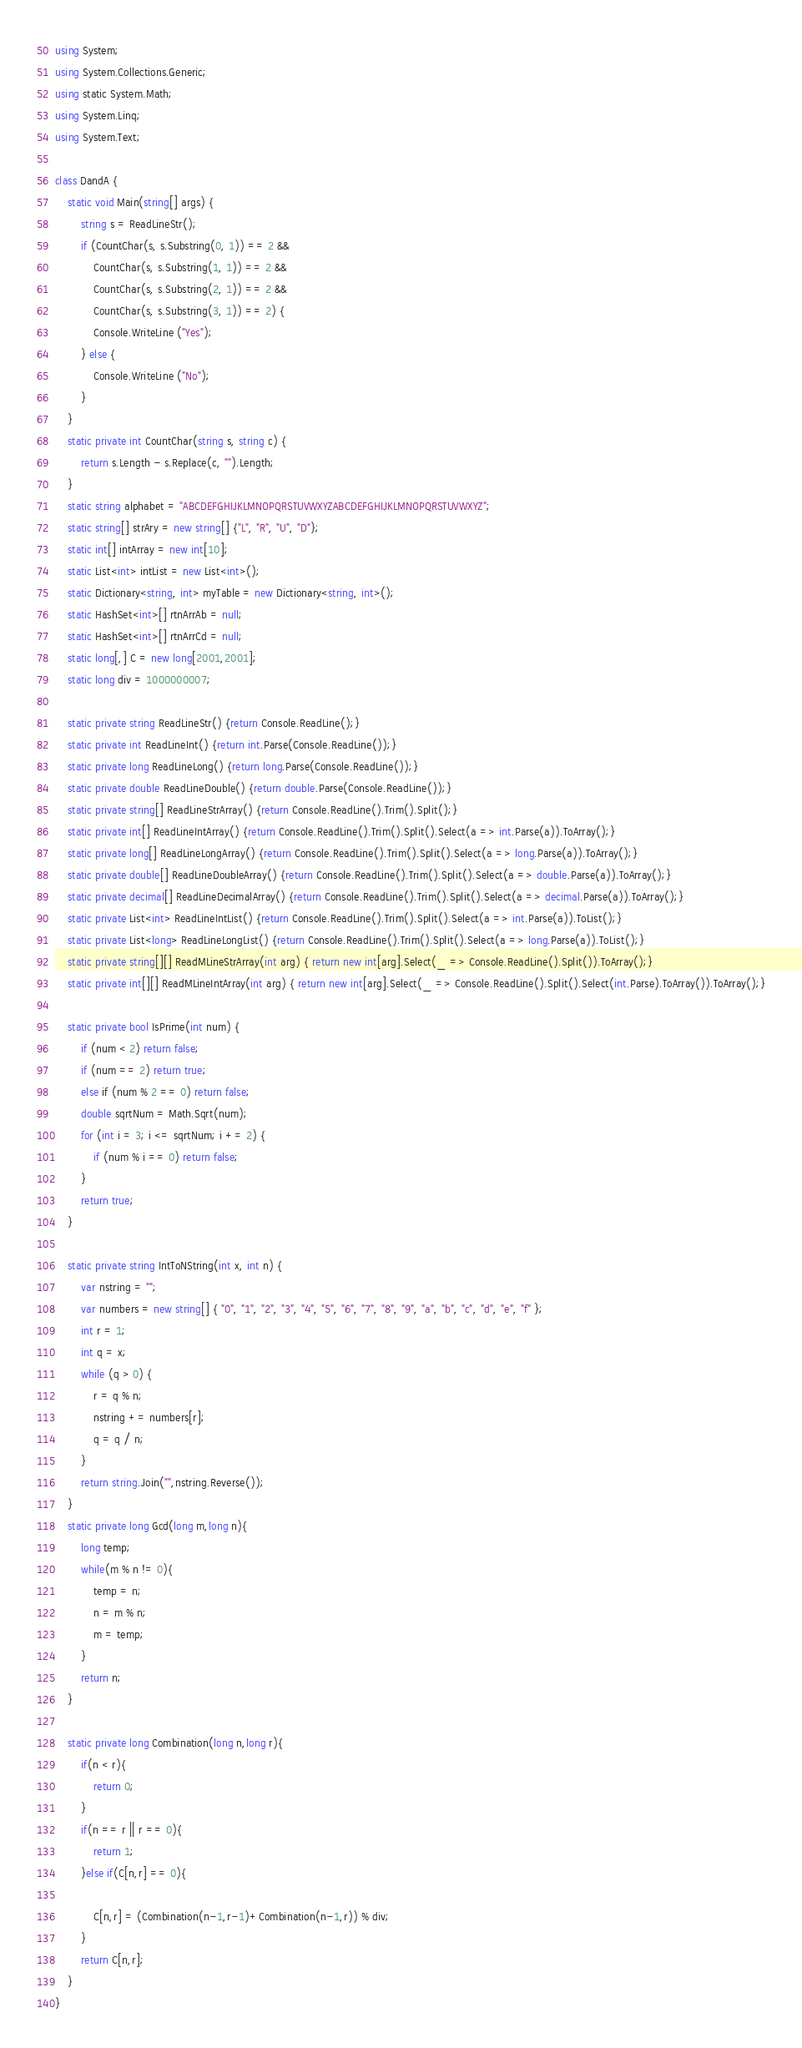<code> <loc_0><loc_0><loc_500><loc_500><_C#_>using System;
using System.Collections.Generic;
using static System.Math;
using System.Linq;
using System.Text;
 
class DandA {
    static void Main(string[] args) {
        string s = ReadLineStr();
        if (CountChar(s, s.Substring(0, 1)) == 2 &&
            CountChar(s, s.Substring(1, 1)) == 2 &&
            CountChar(s, s.Substring(2, 1)) == 2 &&
            CountChar(s, s.Substring(3, 1)) == 2) {
            Console.WriteLine ("Yes");
        } else {
            Console.WriteLine ("No");
        }
    }
    static private int CountChar(string s, string c) {
        return s.Length - s.Replace(c, "").Length;
    }
    static string alphabet = "ABCDEFGHIJKLMNOPQRSTUVWXYZABCDEFGHIJKLMNOPQRSTUVWXYZ";
    static string[] strAry = new string[] {"L", "R", "U", "D"};
    static int[] intArray = new int[10];
    static List<int> intList = new List<int>();
    static Dictionary<string, int> myTable = new Dictionary<string, int>();
    static HashSet<int>[] rtnArrAb = null;
    static HashSet<int>[] rtnArrCd = null;
    static long[,] C = new long[2001,2001];
    static long div = 1000000007;
  
    static private string ReadLineStr() {return Console.ReadLine();}
    static private int ReadLineInt() {return int.Parse(Console.ReadLine());}
    static private long ReadLineLong() {return long.Parse(Console.ReadLine());}
    static private double ReadLineDouble() {return double.Parse(Console.ReadLine());}
    static private string[] ReadLineStrArray() {return Console.ReadLine().Trim().Split();}
    static private int[] ReadLineIntArray() {return Console.ReadLine().Trim().Split().Select(a => int.Parse(a)).ToArray();}
    static private long[] ReadLineLongArray() {return Console.ReadLine().Trim().Split().Select(a => long.Parse(a)).ToArray();}
    static private double[] ReadLineDoubleArray() {return Console.ReadLine().Trim().Split().Select(a => double.Parse(a)).ToArray();}
    static private decimal[] ReadLineDecimalArray() {return Console.ReadLine().Trim().Split().Select(a => decimal.Parse(a)).ToArray();}
    static private List<int> ReadLineIntList() {return Console.ReadLine().Trim().Split().Select(a => int.Parse(a)).ToList();}
    static private List<long> ReadLineLongList() {return Console.ReadLine().Trim().Split().Select(a => long.Parse(a)).ToList();}
    static private string[][] ReadMLineStrArray(int arg) { return new int[arg].Select(_ => Console.ReadLine().Split()).ToArray();}
    static private int[][] ReadMLineIntArray(int arg) { return new int[arg].Select(_ => Console.ReadLine().Split().Select(int.Parse).ToArray()).ToArray();}
 
    static private bool IsPrime(int num) {
        if (num < 2) return false;
        if (num == 2) return true;
        else if (num % 2 == 0) return false;
        double sqrtNum = Math.Sqrt(num);
        for (int i = 3; i <= sqrtNum; i += 2) {
            if (num % i == 0) return false;
        }
        return true;
    }
  
    static private string IntToNString(int x, int n) {
        var nstring = "";
        var numbers = new string[] { "0", "1", "2", "3", "4", "5", "6", "7", "8", "9", "a", "b", "c", "d", "e", "f" };
        int r = 1;
        int q = x;
        while (q > 0) {
            r = q % n;
            nstring += numbers[r];
            q = q / n;
        }
        return string.Join("",nstring.Reverse());
    }
    static private long Gcd(long m,long n){
        long temp;
        while(m % n != 0){
            temp = n;
            n = m % n;
            m = temp;
        }
        return n;
    }

    static private long Combination(long n,long r){
        if(n < r){
            return 0;
        }
        if(n == r || r == 0){
            return 1;
        }else if(C[n,r] == 0){
            
            C[n,r] = (Combination(n-1,r-1)+Combination(n-1,r)) % div;
        }
        return C[n,r];
    }
}</code> 